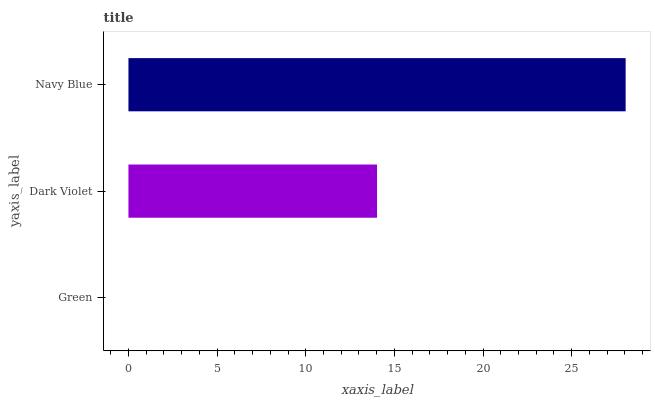Is Green the minimum?
Answer yes or no. Yes. Is Navy Blue the maximum?
Answer yes or no. Yes. Is Dark Violet the minimum?
Answer yes or no. No. Is Dark Violet the maximum?
Answer yes or no. No. Is Dark Violet greater than Green?
Answer yes or no. Yes. Is Green less than Dark Violet?
Answer yes or no. Yes. Is Green greater than Dark Violet?
Answer yes or no. No. Is Dark Violet less than Green?
Answer yes or no. No. Is Dark Violet the high median?
Answer yes or no. Yes. Is Dark Violet the low median?
Answer yes or no. Yes. Is Navy Blue the high median?
Answer yes or no. No. Is Green the low median?
Answer yes or no. No. 